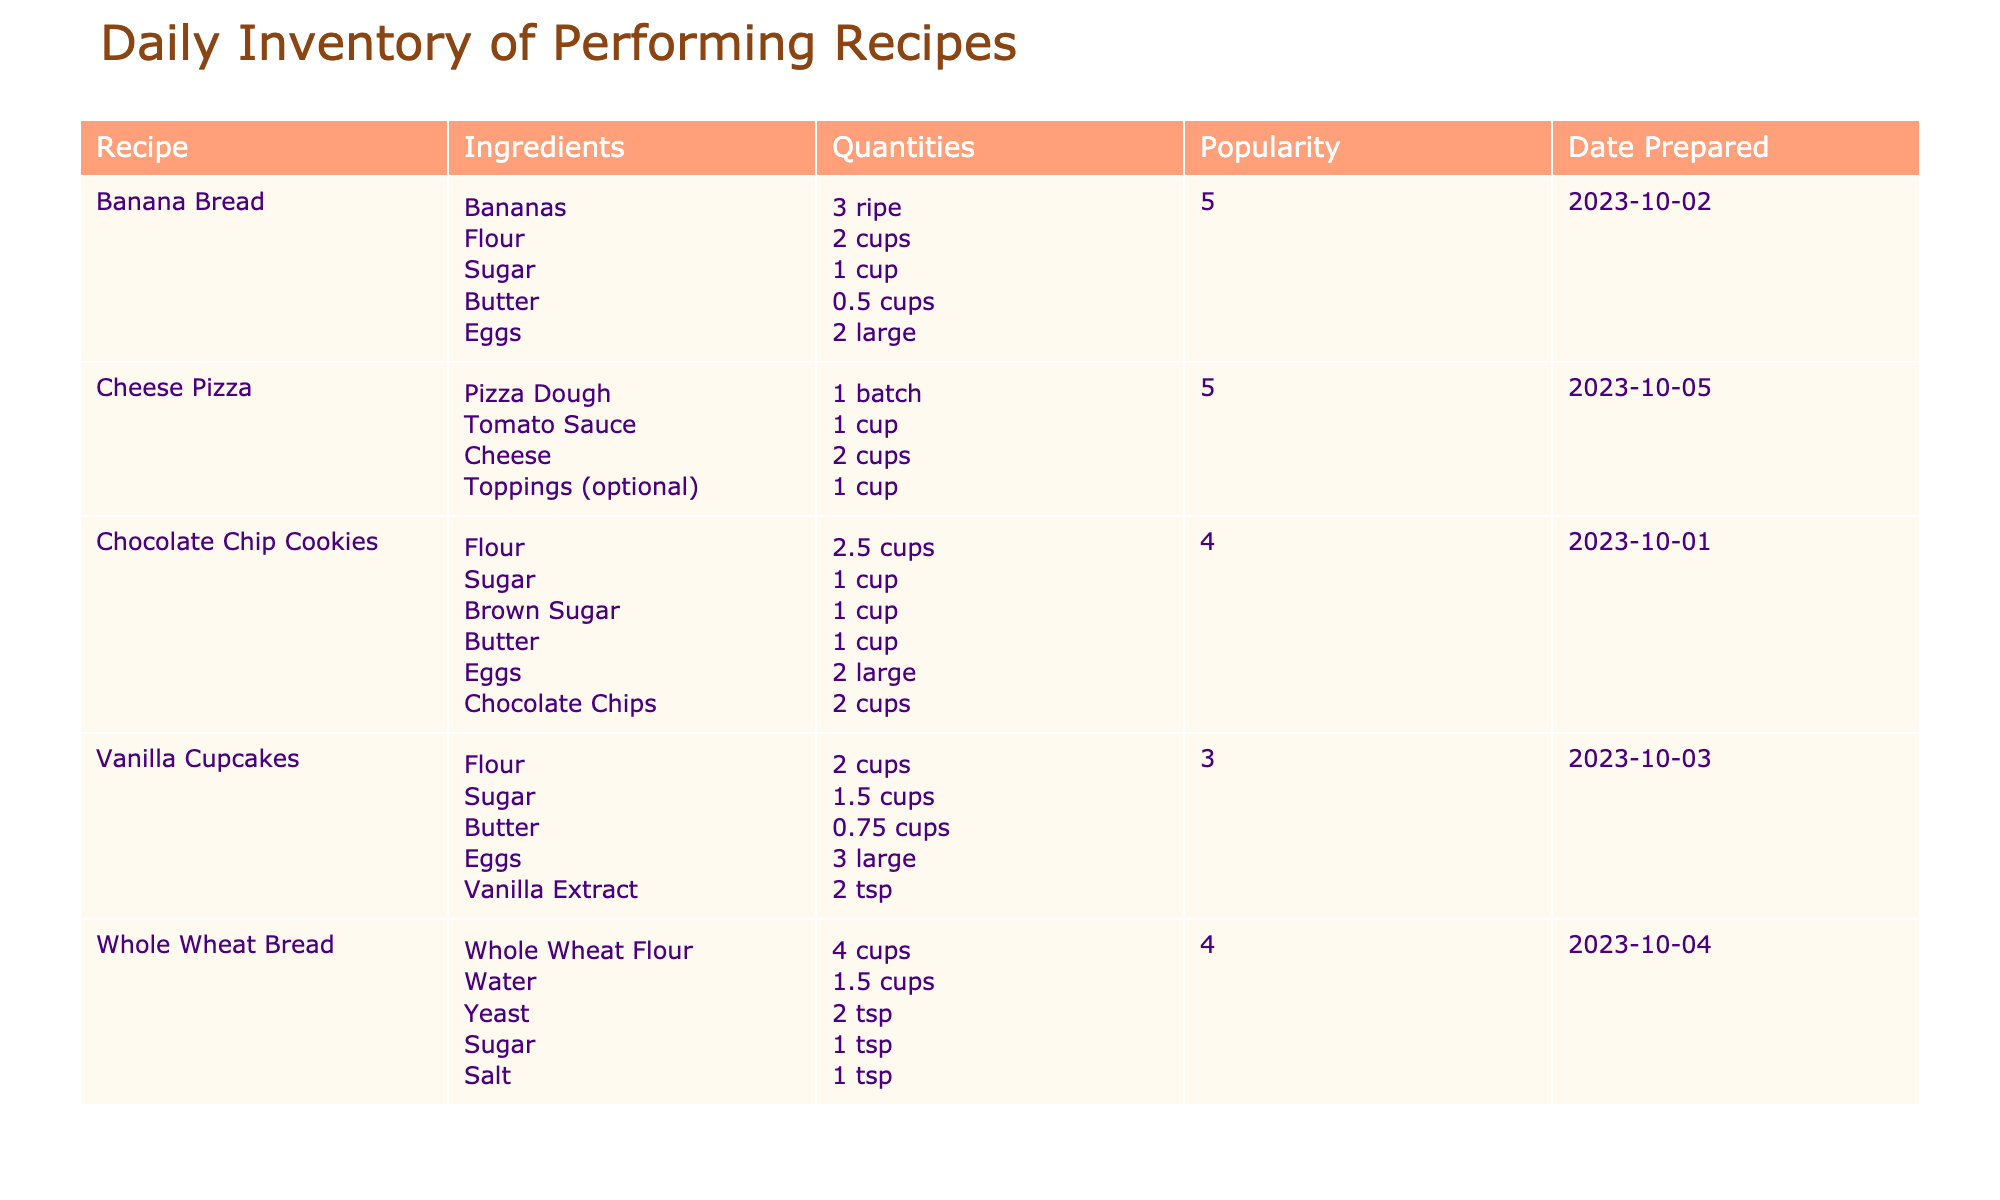What is the popularity rating of Banana Bread? In the table, Banana Bread has a popularity rating indicated in the column titled "Popularity Rating (1-5)". Upon reviewing, the rating is noted as 5.
Answer: 5 How many cups of flour are used in Chocolate Chip Cookies? The table specifies the ingredients for Chocolate Chip Cookies in the "Ingredients" column. For flour, it shows "2.5 cups" in the corresponding "Quantities" column.
Answer: 2.5 cups Which recipe has the highest popularity rating and what is that rating? Looking through the popularity ratings listed, Banana Bread and Cheese Pizza both have the highest rating of 5. These are the only recipes without lower ratings.
Answer: Banana Bread and Cheese Pizza; Rating: 5 What is the total quantity of sugar used in the recipes listed in the table? A quick review of the "Quantity Used (units)" column shows that sugar is used in three recipes: Chocolate Chip Cookies (1 cup), Banana Bread (1 cup), and Vanilla Cupcakes (1.5 cups). Summing these gives: 1 + 1 + 1.5 = 3.5 cups of sugar.
Answer: 3.5 cups Is there a recipe that includes eggs with a popularity rating of 3? In the table, Vanilla Cupcakes is listed with a popularity rating of 3 along with eggs in the ingredients. This confirms the existence of such a recipe.
Answer: Yes What is the difference in popularity rating between Whole Wheat Bread and Vanilla Cupcakes? Assessing the ratings, Whole Wheat Bread has a popularity rating of 4 and Vanilla Cupcakes a rating of 3. The difference calculated is 4 - 3 = 1.
Answer: 1 If I wanted to prepare two batches of Cheese Pizza, how many cups of cheese would I need in total? Cheese Pizza requires 2 cups of cheese for one batch, so for two batches, you would multiply the quantity: 2 cups x 2 = 4 cups total.
Answer: 4 cups Which recipe used the most quantity of flour and how much was used? In the table, Whole Wheat Bread uses 4 cups of whole wheat flour, which is more than any other recipe. Comparing this with Chocolate Chip Cookies (2.5 cups) and Vanilla Cupcakes (2 cups), the highest is clearly Whole Wheat Bread.
Answer: Whole Wheat Bread; 4 cups How many large eggs are used in Banana Bread? The table shows that in the Banana Bread recipe, the quantity for large eggs is listed as 2.
Answer: 2 large eggs 